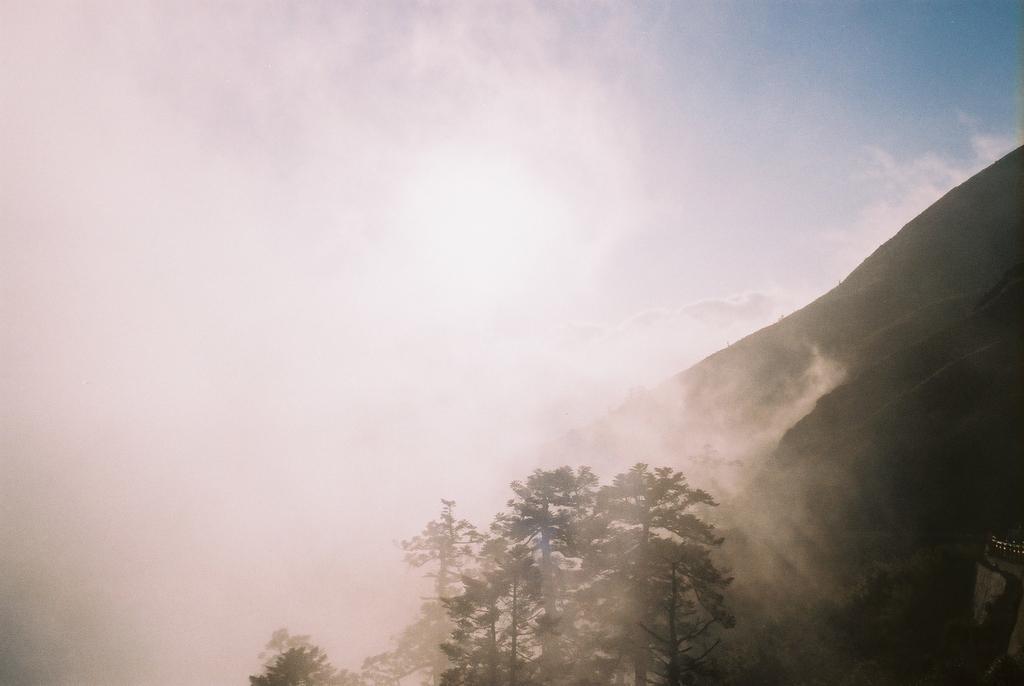Please provide a concise description of this image. In this image I can see few trees, mountains and fog. The sky is in blue color. 